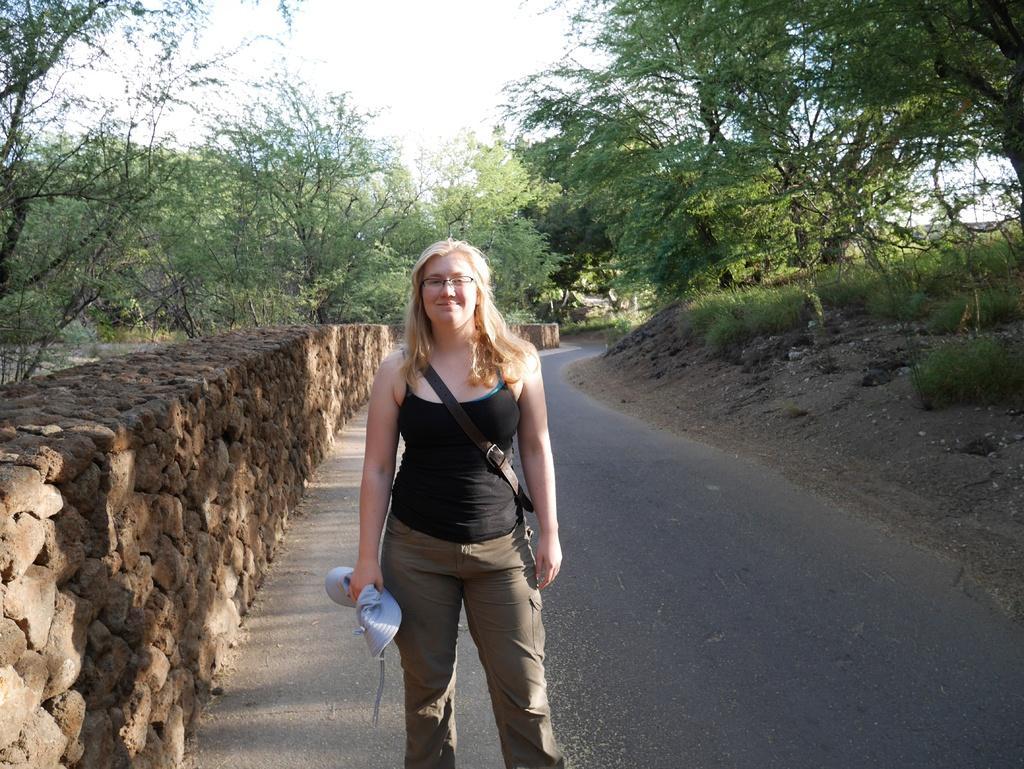How would you summarize this image in a sentence or two? In this picture we can see a woman standing here, in the background there are some trees, we can see the sky at the top of the picture, on the right side there is grass, this woman is holding something. 